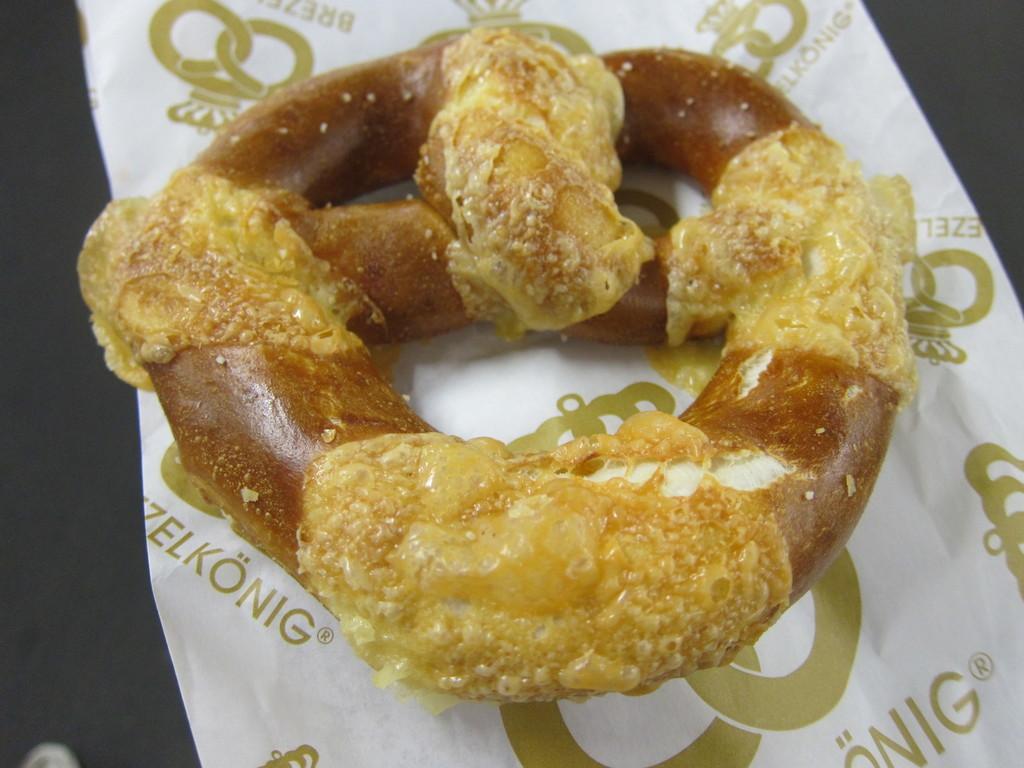In one or two sentences, can you explain what this image depicts? In this image I can see the food on the white color paper. I can see something is written on the paper. And the food is in brown color. 